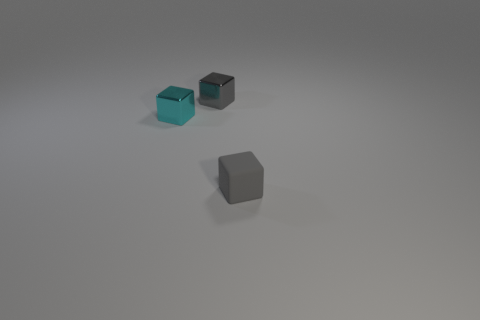Add 1 gray blocks. How many objects exist? 4 Subtract all cyan blocks. How many blocks are left? 2 Subtract all gray metal cubes. How many cubes are left? 2 Subtract 1 cubes. How many cubes are left? 2 Subtract all red blocks. Subtract all purple cylinders. How many blocks are left? 3 Subtract all red balls. How many cyan blocks are left? 1 Subtract all gray matte things. Subtract all cyan metallic things. How many objects are left? 1 Add 1 tiny things. How many tiny things are left? 4 Add 3 small yellow metal objects. How many small yellow metal objects exist? 3 Subtract 0 red spheres. How many objects are left? 3 